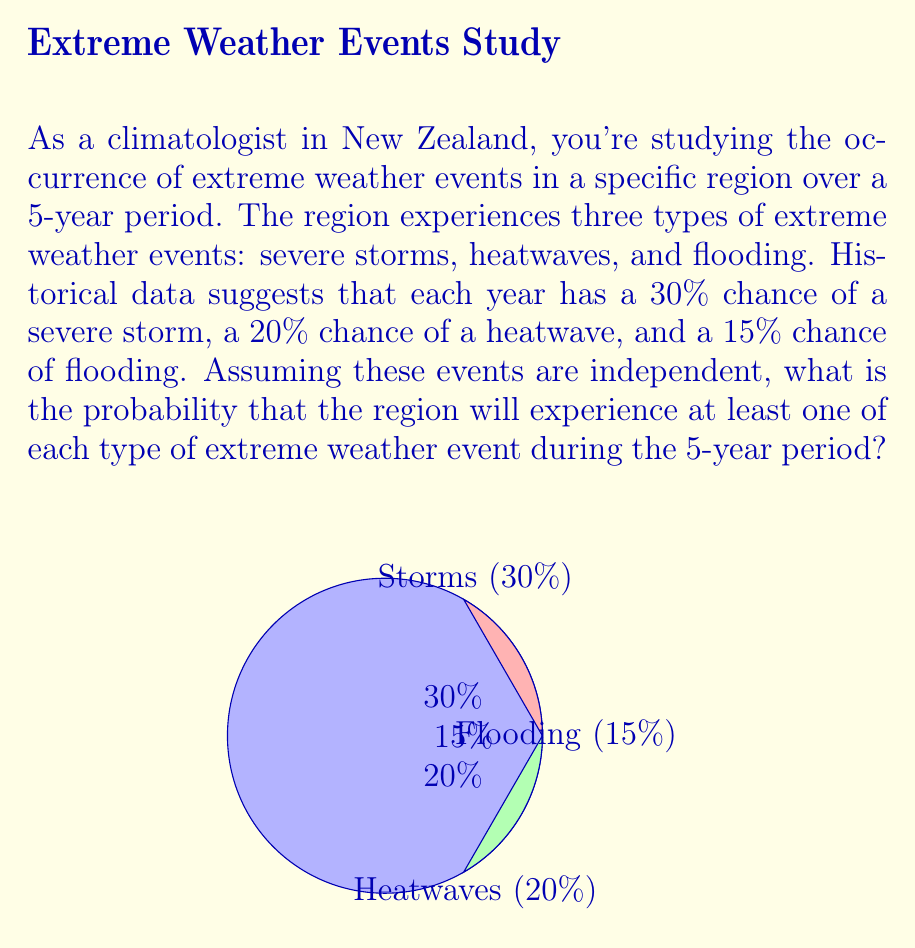Show me your answer to this math problem. Let's approach this problem step-by-step using combinatorics and probability theory:

1) First, we need to calculate the probability of each event NOT occurring in a single year:
   - No severe storm: $1 - 0.30 = 0.70$
   - No heatwave: $1 - 0.20 = 0.80$
   - No flooding: $1 - 0.15 = 0.85$

2) Now, we need to calculate the probability of each event NOT occurring for all 5 years:
   - No severe storm in 5 years: $0.70^5 \approx 0.16807$
   - No heatwave in 5 years: $0.80^5 \approx 0.32768$
   - No flooding in 5 years: $0.85^5 \approx 0.44371$

3) The probability of experiencing at least one of each type of event is the opposite of NOT experiencing at least one of any type. So, we need to subtract the probability of missing at least one type of event from 1.

4) The probability of missing at least one type of event can be calculated using the inclusion-exclusion principle:

   $P(\text{miss at least one}) = P(S) + P(H) + P(F) - P(S \cap H) - P(S \cap F) - P(H \cap F) + P(S \cap H \cap F)$

   Where $S$, $H$, and $F$ represent the events of missing storms, heatwaves, and floods respectively over the 5-year period.

5) Substituting the values:

   $P(\text{miss at least one}) = 0.16807 + 0.32768 + 0.44371 - (0.16807 \times 0.32768) - (0.16807 \times 0.44371) - (0.32768 \times 0.44371) + (0.16807 \times 0.32768 \times 0.44371)$

6) Calculating:

   $P(\text{miss at least one}) \approx 0.69697$

7) Therefore, the probability of experiencing at least one of each type of event is:

   $P(\text{at least one of each}) = 1 - P(\text{miss at least one}) \approx 1 - 0.69697 = 0.30303$
Answer: $\approx 0.30303$ or $30.303\%$ 